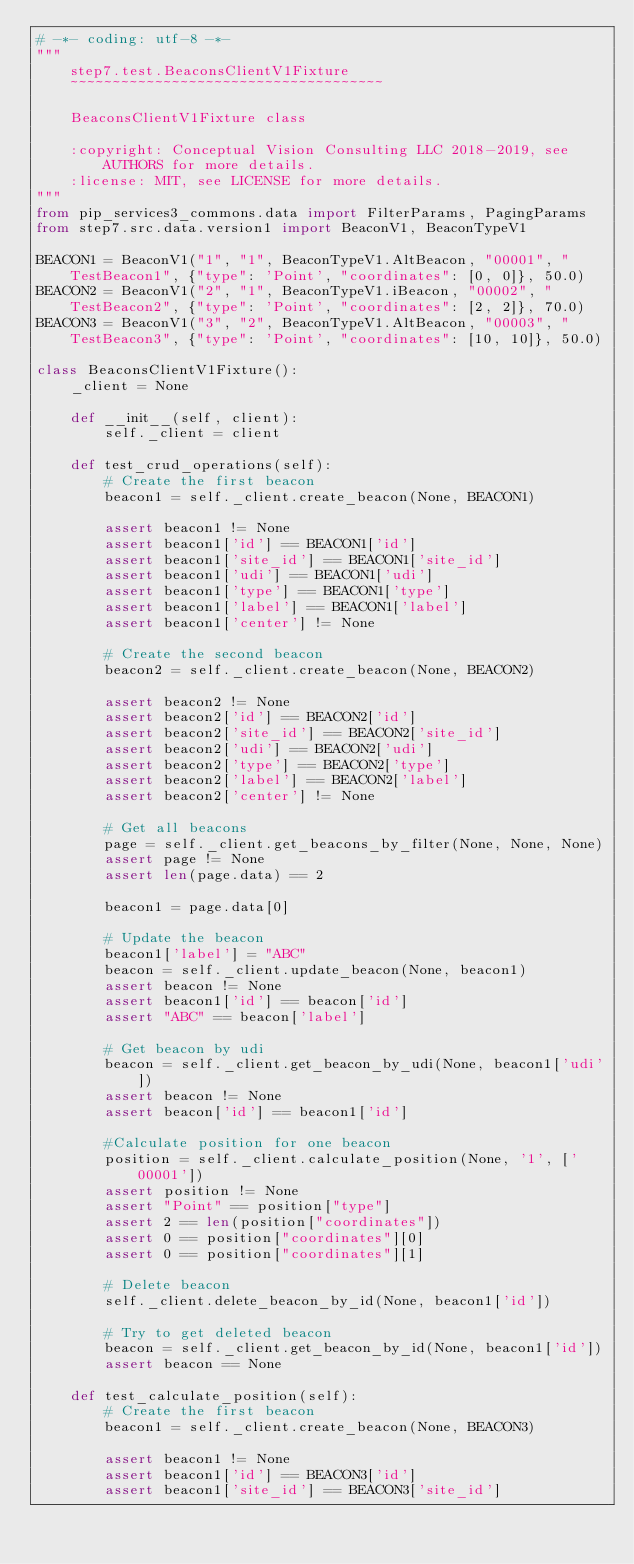<code> <loc_0><loc_0><loc_500><loc_500><_Python_># -*- coding: utf-8 -*-
"""
    step7.test.BeaconsClientV1Fixture
    ~~~~~~~~~~~~~~~~~~~~~~~~~~~~~~~~~~~~~

    BeaconsClientV1Fixture class

    :copyright: Conceptual Vision Consulting LLC 2018-2019, see AUTHORS for more details.
    :license: MIT, see LICENSE for more details.
"""
from pip_services3_commons.data import FilterParams, PagingParams
from step7.src.data.version1 import BeaconV1, BeaconTypeV1

BEACON1 = BeaconV1("1", "1", BeaconTypeV1.AltBeacon, "00001", "TestBeacon1", {"type": 'Point', "coordinates": [0, 0]}, 50.0)
BEACON2 = BeaconV1("2", "1", BeaconTypeV1.iBeacon, "00002", "TestBeacon2", {"type": 'Point', "coordinates": [2, 2]}, 70.0)
BEACON3 = BeaconV1("3", "2", BeaconTypeV1.AltBeacon, "00003", "TestBeacon3", {"type": 'Point', "coordinates": [10, 10]}, 50.0)

class BeaconsClientV1Fixture():
    _client = None

    def __init__(self, client):
        self._client = client

    def test_crud_operations(self):
        # Create the first beacon
        beacon1 = self._client.create_beacon(None, BEACON1)

        assert beacon1 != None
        assert beacon1['id'] == BEACON1['id']
        assert beacon1['site_id'] == BEACON1['site_id']
        assert beacon1['udi'] == BEACON1['udi']
        assert beacon1['type'] == BEACON1['type']
        assert beacon1['label'] == BEACON1['label']
        assert beacon1['center'] != None

        # Create the second beacon
        beacon2 = self._client.create_beacon(None, BEACON2)

        assert beacon2 != None
        assert beacon2['id'] == BEACON2['id']
        assert beacon2['site_id'] == BEACON2['site_id']
        assert beacon2['udi'] == BEACON2['udi']
        assert beacon2['type'] == BEACON2['type']
        assert beacon2['label'] == BEACON2['label']
        assert beacon2['center'] != None

        # Get all beacons
        page = self._client.get_beacons_by_filter(None, None, None)
        assert page != None
        assert len(page.data) == 2

        beacon1 = page.data[0]

        # Update the beacon
        beacon1['label'] = "ABC"
        beacon = self._client.update_beacon(None, beacon1)
        assert beacon != None
        assert beacon1['id'] == beacon['id']
        assert "ABC" == beacon['label']

        # Get beacon by udi
        beacon = self._client.get_beacon_by_udi(None, beacon1['udi'])
        assert beacon != None
        assert beacon['id'] == beacon1['id']

        #Calculate position for one beacon
        position = self._client.calculate_position(None, '1', ['00001'])
        assert position != None
        assert "Point" == position["type"]
        assert 2 == len(position["coordinates"])
        assert 0 == position["coordinates"][0]
        assert 0 == position["coordinates"][1]

        # Delete beacon
        self._client.delete_beacon_by_id(None, beacon1['id'])

        # Try to get deleted beacon
        beacon = self._client.get_beacon_by_id(None, beacon1['id'])
        assert beacon == None

    def test_calculate_position(self):
        # Create the first beacon
        beacon1 = self._client.create_beacon(None, BEACON3)

        assert beacon1 != None
        assert beacon1['id'] == BEACON3['id']
        assert beacon1['site_id'] == BEACON3['site_id']</code> 